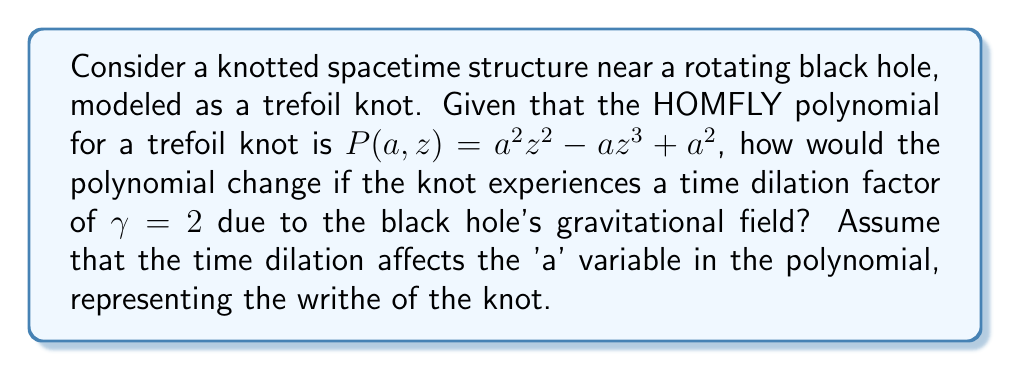Give your solution to this math problem. To solve this problem, we need to follow these steps:

1) Recall the original HOMFLY polynomial for the trefoil knot:
   $$P(a,z) = a^2z^2 - az^3 + a^2$$

2) The time dilation factor $\gamma = 2$ affects the 'a' variable, which represents the writhe of the knot. In the vicinity of a black hole, time runs slower, so we need to adjust 'a' by dividing it by $\gamma$:
   $$a_{new} = \frac{a}{\gamma} = \frac{a}{2}$$

3) Substitute this new 'a' value into the original polynomial:
   $$P_{new}(a,z) = (\frac{a}{2})^2z^2 - (\frac{a}{2})z^3 + (\frac{a}{2})^2$$

4) Simplify the expression:
   $$P_{new}(a,z) = \frac{a^2}{4}z^2 - \frac{a}{2}z^3 + \frac{a^2}{4}$$

5) Factor out $\frac{1}{4}$:
   $$P_{new}(a,z) = \frac{1}{4}(a^2z^2 - 2az^3 + a^2)$$

This is the new HOMFLY polynomial for the knotted spacetime structure experiencing time dilation near the black hole.
Answer: $P_{new}(a,z) = \frac{1}{4}(a^2z^2 - 2az^3 + a^2)$ 